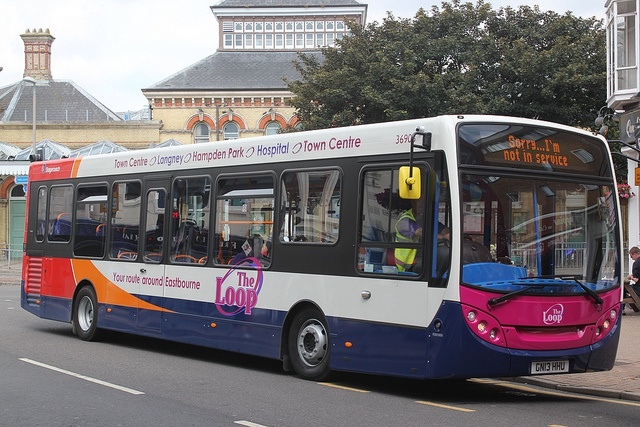Describe the objects in this image and their specific colors. I can see bus in white, black, gray, lightgray, and navy tones, people in white, black, gray, darkgreen, and olive tones, people in white, gray, black, and navy tones, and people in white, black, brown, and maroon tones in this image. 